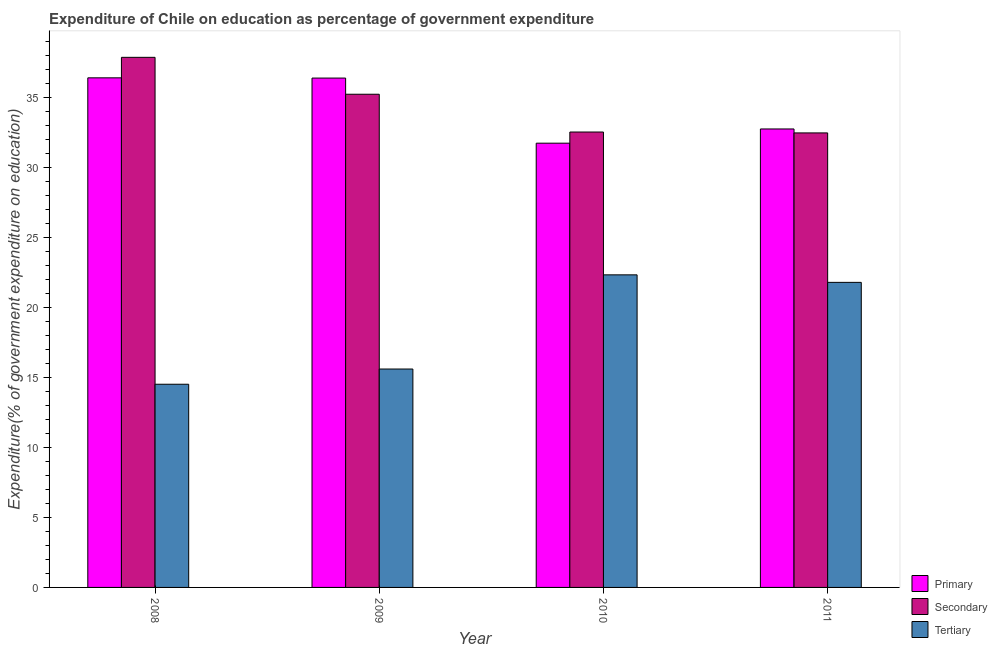How many groups of bars are there?
Provide a short and direct response. 4. Are the number of bars per tick equal to the number of legend labels?
Your answer should be compact. Yes. What is the label of the 3rd group of bars from the left?
Ensure brevity in your answer.  2010. What is the expenditure on secondary education in 2009?
Make the answer very short. 35.23. Across all years, what is the maximum expenditure on primary education?
Your answer should be compact. 36.4. Across all years, what is the minimum expenditure on primary education?
Provide a short and direct response. 31.74. What is the total expenditure on tertiary education in the graph?
Your answer should be very brief. 74.24. What is the difference between the expenditure on primary education in 2010 and that in 2011?
Your answer should be very brief. -1.02. What is the difference between the expenditure on secondary education in 2011 and the expenditure on primary education in 2009?
Your answer should be compact. -2.76. What is the average expenditure on primary education per year?
Offer a very short reply. 34.32. What is the ratio of the expenditure on secondary education in 2008 to that in 2010?
Make the answer very short. 1.16. What is the difference between the highest and the second highest expenditure on primary education?
Your response must be concise. 0.02. What is the difference between the highest and the lowest expenditure on primary education?
Give a very brief answer. 4.67. In how many years, is the expenditure on tertiary education greater than the average expenditure on tertiary education taken over all years?
Give a very brief answer. 2. What does the 1st bar from the left in 2008 represents?
Make the answer very short. Primary. What does the 3rd bar from the right in 2011 represents?
Ensure brevity in your answer.  Primary. Is it the case that in every year, the sum of the expenditure on primary education and expenditure on secondary education is greater than the expenditure on tertiary education?
Provide a short and direct response. Yes. How many bars are there?
Keep it short and to the point. 12. Are all the bars in the graph horizontal?
Offer a very short reply. No. Are the values on the major ticks of Y-axis written in scientific E-notation?
Your answer should be compact. No. Does the graph contain any zero values?
Offer a very short reply. No. What is the title of the graph?
Provide a succinct answer. Expenditure of Chile on education as percentage of government expenditure. Does "New Zealand" appear as one of the legend labels in the graph?
Your response must be concise. No. What is the label or title of the Y-axis?
Ensure brevity in your answer.  Expenditure(% of government expenditure on education). What is the Expenditure(% of government expenditure on education) of Primary in 2008?
Make the answer very short. 36.4. What is the Expenditure(% of government expenditure on education) in Secondary in 2008?
Provide a short and direct response. 37.87. What is the Expenditure(% of government expenditure on education) in Tertiary in 2008?
Give a very brief answer. 14.51. What is the Expenditure(% of government expenditure on education) in Primary in 2009?
Ensure brevity in your answer.  36.39. What is the Expenditure(% of government expenditure on education) of Secondary in 2009?
Offer a very short reply. 35.23. What is the Expenditure(% of government expenditure on education) in Tertiary in 2009?
Ensure brevity in your answer.  15.6. What is the Expenditure(% of government expenditure on education) in Primary in 2010?
Give a very brief answer. 31.74. What is the Expenditure(% of government expenditure on education) of Secondary in 2010?
Give a very brief answer. 32.53. What is the Expenditure(% of government expenditure on education) of Tertiary in 2010?
Provide a short and direct response. 22.33. What is the Expenditure(% of government expenditure on education) of Primary in 2011?
Your answer should be compact. 32.75. What is the Expenditure(% of government expenditure on education) in Secondary in 2011?
Your response must be concise. 32.47. What is the Expenditure(% of government expenditure on education) in Tertiary in 2011?
Give a very brief answer. 21.79. Across all years, what is the maximum Expenditure(% of government expenditure on education) of Primary?
Provide a short and direct response. 36.4. Across all years, what is the maximum Expenditure(% of government expenditure on education) of Secondary?
Provide a succinct answer. 37.87. Across all years, what is the maximum Expenditure(% of government expenditure on education) of Tertiary?
Your answer should be very brief. 22.33. Across all years, what is the minimum Expenditure(% of government expenditure on education) of Primary?
Provide a short and direct response. 31.74. Across all years, what is the minimum Expenditure(% of government expenditure on education) in Secondary?
Provide a succinct answer. 32.47. Across all years, what is the minimum Expenditure(% of government expenditure on education) of Tertiary?
Provide a succinct answer. 14.51. What is the total Expenditure(% of government expenditure on education) in Primary in the graph?
Your answer should be very brief. 137.28. What is the total Expenditure(% of government expenditure on education) of Secondary in the graph?
Give a very brief answer. 138.1. What is the total Expenditure(% of government expenditure on education) in Tertiary in the graph?
Your response must be concise. 74.24. What is the difference between the Expenditure(% of government expenditure on education) of Primary in 2008 and that in 2009?
Your answer should be compact. 0.02. What is the difference between the Expenditure(% of government expenditure on education) in Secondary in 2008 and that in 2009?
Offer a very short reply. 2.64. What is the difference between the Expenditure(% of government expenditure on education) in Tertiary in 2008 and that in 2009?
Keep it short and to the point. -1.09. What is the difference between the Expenditure(% of government expenditure on education) of Primary in 2008 and that in 2010?
Provide a succinct answer. 4.67. What is the difference between the Expenditure(% of government expenditure on education) of Secondary in 2008 and that in 2010?
Your answer should be compact. 5.34. What is the difference between the Expenditure(% of government expenditure on education) of Tertiary in 2008 and that in 2010?
Provide a short and direct response. -7.82. What is the difference between the Expenditure(% of government expenditure on education) of Primary in 2008 and that in 2011?
Make the answer very short. 3.65. What is the difference between the Expenditure(% of government expenditure on education) of Secondary in 2008 and that in 2011?
Keep it short and to the point. 5.4. What is the difference between the Expenditure(% of government expenditure on education) of Tertiary in 2008 and that in 2011?
Give a very brief answer. -7.28. What is the difference between the Expenditure(% of government expenditure on education) in Primary in 2009 and that in 2010?
Offer a terse response. 4.65. What is the difference between the Expenditure(% of government expenditure on education) of Secondary in 2009 and that in 2010?
Make the answer very short. 2.7. What is the difference between the Expenditure(% of government expenditure on education) in Tertiary in 2009 and that in 2010?
Your answer should be compact. -6.73. What is the difference between the Expenditure(% of government expenditure on education) in Primary in 2009 and that in 2011?
Your answer should be very brief. 3.64. What is the difference between the Expenditure(% of government expenditure on education) in Secondary in 2009 and that in 2011?
Your answer should be compact. 2.76. What is the difference between the Expenditure(% of government expenditure on education) of Tertiary in 2009 and that in 2011?
Offer a very short reply. -6.19. What is the difference between the Expenditure(% of government expenditure on education) in Primary in 2010 and that in 2011?
Keep it short and to the point. -1.02. What is the difference between the Expenditure(% of government expenditure on education) in Secondary in 2010 and that in 2011?
Keep it short and to the point. 0.06. What is the difference between the Expenditure(% of government expenditure on education) of Tertiary in 2010 and that in 2011?
Offer a very short reply. 0.54. What is the difference between the Expenditure(% of government expenditure on education) of Primary in 2008 and the Expenditure(% of government expenditure on education) of Secondary in 2009?
Give a very brief answer. 1.17. What is the difference between the Expenditure(% of government expenditure on education) in Primary in 2008 and the Expenditure(% of government expenditure on education) in Tertiary in 2009?
Provide a short and direct response. 20.8. What is the difference between the Expenditure(% of government expenditure on education) in Secondary in 2008 and the Expenditure(% of government expenditure on education) in Tertiary in 2009?
Make the answer very short. 22.27. What is the difference between the Expenditure(% of government expenditure on education) of Primary in 2008 and the Expenditure(% of government expenditure on education) of Secondary in 2010?
Your answer should be very brief. 3.87. What is the difference between the Expenditure(% of government expenditure on education) in Primary in 2008 and the Expenditure(% of government expenditure on education) in Tertiary in 2010?
Your answer should be very brief. 14.07. What is the difference between the Expenditure(% of government expenditure on education) in Secondary in 2008 and the Expenditure(% of government expenditure on education) in Tertiary in 2010?
Keep it short and to the point. 15.54. What is the difference between the Expenditure(% of government expenditure on education) of Primary in 2008 and the Expenditure(% of government expenditure on education) of Secondary in 2011?
Your answer should be compact. 3.93. What is the difference between the Expenditure(% of government expenditure on education) in Primary in 2008 and the Expenditure(% of government expenditure on education) in Tertiary in 2011?
Your answer should be compact. 14.61. What is the difference between the Expenditure(% of government expenditure on education) in Secondary in 2008 and the Expenditure(% of government expenditure on education) in Tertiary in 2011?
Your response must be concise. 16.08. What is the difference between the Expenditure(% of government expenditure on education) of Primary in 2009 and the Expenditure(% of government expenditure on education) of Secondary in 2010?
Give a very brief answer. 3.85. What is the difference between the Expenditure(% of government expenditure on education) of Primary in 2009 and the Expenditure(% of government expenditure on education) of Tertiary in 2010?
Give a very brief answer. 14.06. What is the difference between the Expenditure(% of government expenditure on education) of Secondary in 2009 and the Expenditure(% of government expenditure on education) of Tertiary in 2010?
Your response must be concise. 12.9. What is the difference between the Expenditure(% of government expenditure on education) of Primary in 2009 and the Expenditure(% of government expenditure on education) of Secondary in 2011?
Your answer should be very brief. 3.92. What is the difference between the Expenditure(% of government expenditure on education) of Primary in 2009 and the Expenditure(% of government expenditure on education) of Tertiary in 2011?
Offer a very short reply. 14.59. What is the difference between the Expenditure(% of government expenditure on education) of Secondary in 2009 and the Expenditure(% of government expenditure on education) of Tertiary in 2011?
Make the answer very short. 13.44. What is the difference between the Expenditure(% of government expenditure on education) in Primary in 2010 and the Expenditure(% of government expenditure on education) in Secondary in 2011?
Provide a short and direct response. -0.73. What is the difference between the Expenditure(% of government expenditure on education) of Primary in 2010 and the Expenditure(% of government expenditure on education) of Tertiary in 2011?
Your answer should be compact. 9.94. What is the difference between the Expenditure(% of government expenditure on education) in Secondary in 2010 and the Expenditure(% of government expenditure on education) in Tertiary in 2011?
Keep it short and to the point. 10.74. What is the average Expenditure(% of government expenditure on education) in Primary per year?
Offer a very short reply. 34.32. What is the average Expenditure(% of government expenditure on education) in Secondary per year?
Ensure brevity in your answer.  34.53. What is the average Expenditure(% of government expenditure on education) in Tertiary per year?
Ensure brevity in your answer.  18.56. In the year 2008, what is the difference between the Expenditure(% of government expenditure on education) of Primary and Expenditure(% of government expenditure on education) of Secondary?
Make the answer very short. -1.46. In the year 2008, what is the difference between the Expenditure(% of government expenditure on education) in Primary and Expenditure(% of government expenditure on education) in Tertiary?
Provide a succinct answer. 21.89. In the year 2008, what is the difference between the Expenditure(% of government expenditure on education) in Secondary and Expenditure(% of government expenditure on education) in Tertiary?
Offer a very short reply. 23.35. In the year 2009, what is the difference between the Expenditure(% of government expenditure on education) in Primary and Expenditure(% of government expenditure on education) in Secondary?
Your response must be concise. 1.15. In the year 2009, what is the difference between the Expenditure(% of government expenditure on education) in Primary and Expenditure(% of government expenditure on education) in Tertiary?
Give a very brief answer. 20.79. In the year 2009, what is the difference between the Expenditure(% of government expenditure on education) in Secondary and Expenditure(% of government expenditure on education) in Tertiary?
Give a very brief answer. 19.63. In the year 2010, what is the difference between the Expenditure(% of government expenditure on education) of Primary and Expenditure(% of government expenditure on education) of Secondary?
Your answer should be very brief. -0.8. In the year 2010, what is the difference between the Expenditure(% of government expenditure on education) of Primary and Expenditure(% of government expenditure on education) of Tertiary?
Ensure brevity in your answer.  9.41. In the year 2010, what is the difference between the Expenditure(% of government expenditure on education) in Secondary and Expenditure(% of government expenditure on education) in Tertiary?
Your answer should be very brief. 10.2. In the year 2011, what is the difference between the Expenditure(% of government expenditure on education) in Primary and Expenditure(% of government expenditure on education) in Secondary?
Make the answer very short. 0.28. In the year 2011, what is the difference between the Expenditure(% of government expenditure on education) of Primary and Expenditure(% of government expenditure on education) of Tertiary?
Make the answer very short. 10.96. In the year 2011, what is the difference between the Expenditure(% of government expenditure on education) in Secondary and Expenditure(% of government expenditure on education) in Tertiary?
Provide a succinct answer. 10.68. What is the ratio of the Expenditure(% of government expenditure on education) in Secondary in 2008 to that in 2009?
Offer a very short reply. 1.07. What is the ratio of the Expenditure(% of government expenditure on education) in Tertiary in 2008 to that in 2009?
Provide a short and direct response. 0.93. What is the ratio of the Expenditure(% of government expenditure on education) of Primary in 2008 to that in 2010?
Your answer should be very brief. 1.15. What is the ratio of the Expenditure(% of government expenditure on education) of Secondary in 2008 to that in 2010?
Provide a succinct answer. 1.16. What is the ratio of the Expenditure(% of government expenditure on education) of Tertiary in 2008 to that in 2010?
Your answer should be very brief. 0.65. What is the ratio of the Expenditure(% of government expenditure on education) of Primary in 2008 to that in 2011?
Provide a short and direct response. 1.11. What is the ratio of the Expenditure(% of government expenditure on education) of Secondary in 2008 to that in 2011?
Your answer should be compact. 1.17. What is the ratio of the Expenditure(% of government expenditure on education) in Tertiary in 2008 to that in 2011?
Provide a succinct answer. 0.67. What is the ratio of the Expenditure(% of government expenditure on education) of Primary in 2009 to that in 2010?
Keep it short and to the point. 1.15. What is the ratio of the Expenditure(% of government expenditure on education) in Secondary in 2009 to that in 2010?
Your answer should be very brief. 1.08. What is the ratio of the Expenditure(% of government expenditure on education) in Tertiary in 2009 to that in 2010?
Your response must be concise. 0.7. What is the ratio of the Expenditure(% of government expenditure on education) of Primary in 2009 to that in 2011?
Make the answer very short. 1.11. What is the ratio of the Expenditure(% of government expenditure on education) in Secondary in 2009 to that in 2011?
Offer a terse response. 1.09. What is the ratio of the Expenditure(% of government expenditure on education) in Tertiary in 2009 to that in 2011?
Your response must be concise. 0.72. What is the ratio of the Expenditure(% of government expenditure on education) in Tertiary in 2010 to that in 2011?
Your answer should be compact. 1.02. What is the difference between the highest and the second highest Expenditure(% of government expenditure on education) of Primary?
Give a very brief answer. 0.02. What is the difference between the highest and the second highest Expenditure(% of government expenditure on education) in Secondary?
Make the answer very short. 2.64. What is the difference between the highest and the second highest Expenditure(% of government expenditure on education) in Tertiary?
Ensure brevity in your answer.  0.54. What is the difference between the highest and the lowest Expenditure(% of government expenditure on education) of Primary?
Give a very brief answer. 4.67. What is the difference between the highest and the lowest Expenditure(% of government expenditure on education) of Secondary?
Keep it short and to the point. 5.4. What is the difference between the highest and the lowest Expenditure(% of government expenditure on education) in Tertiary?
Give a very brief answer. 7.82. 